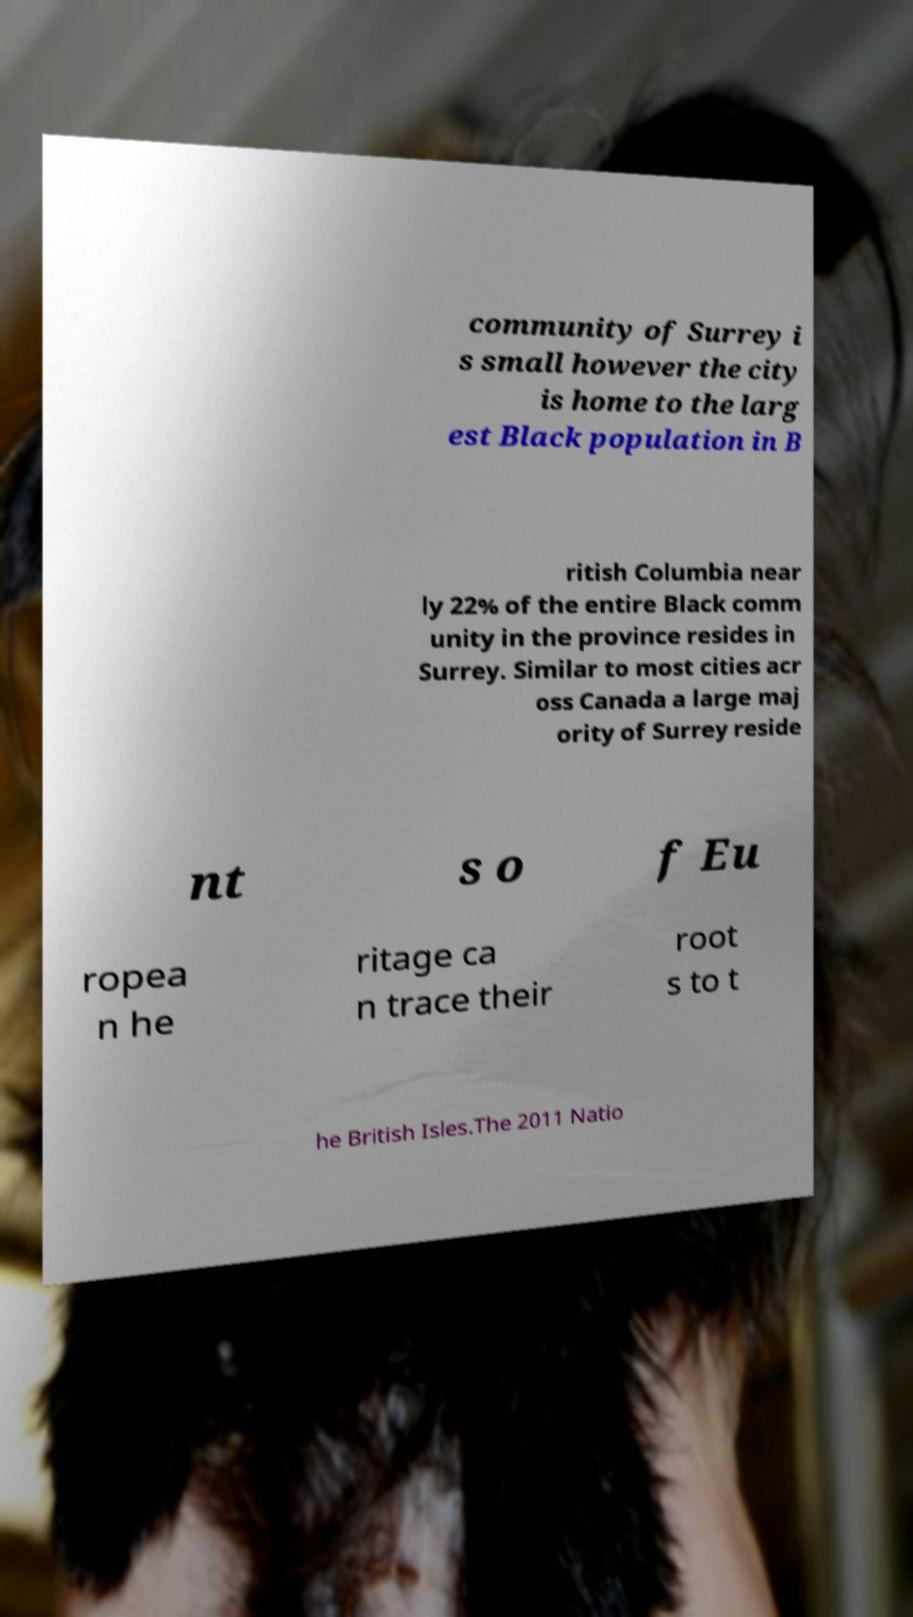Could you extract and type out the text from this image? community of Surrey i s small however the city is home to the larg est Black population in B ritish Columbia near ly 22% of the entire Black comm unity in the province resides in Surrey. Similar to most cities acr oss Canada a large maj ority of Surrey reside nt s o f Eu ropea n he ritage ca n trace their root s to t he British Isles.The 2011 Natio 